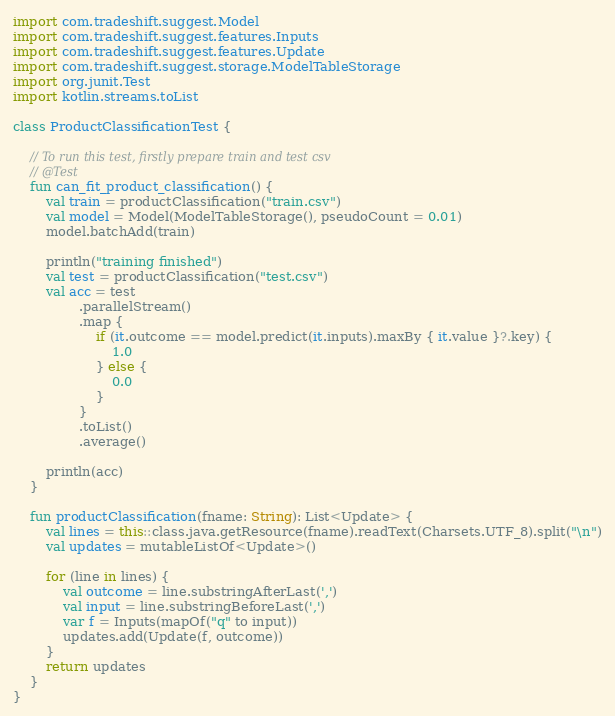Convert code to text. <code><loc_0><loc_0><loc_500><loc_500><_Kotlin_>import com.tradeshift.suggest.Model
import com.tradeshift.suggest.features.Inputs
import com.tradeshift.suggest.features.Update
import com.tradeshift.suggest.storage.ModelTableStorage
import org.junit.Test
import kotlin.streams.toList

class ProductClassificationTest {

    // To run this test, firstly prepare train and test csv
    // @Test
    fun can_fit_product_classification() {
        val train = productClassification("train.csv")
        val model = Model(ModelTableStorage(), pseudoCount = 0.01)
        model.batchAdd(train)

        println("training finished")
        val test = productClassification("test.csv")
        val acc = test
                .parallelStream()
                .map {
                    if (it.outcome == model.predict(it.inputs).maxBy { it.value }?.key) {
                        1.0
                    } else {
                        0.0
                    }
                }
                .toList()
                .average()

        println(acc)
    }

    fun productClassification(fname: String): List<Update> {
        val lines = this::class.java.getResource(fname).readText(Charsets.UTF_8).split("\n")
        val updates = mutableListOf<Update>()

        for (line in lines) {
            val outcome = line.substringAfterLast(',')
            val input = line.substringBeforeLast(',')
            var f = Inputs(mapOf("q" to input))
            updates.add(Update(f, outcome))
        }
        return updates
    }
}

</code> 